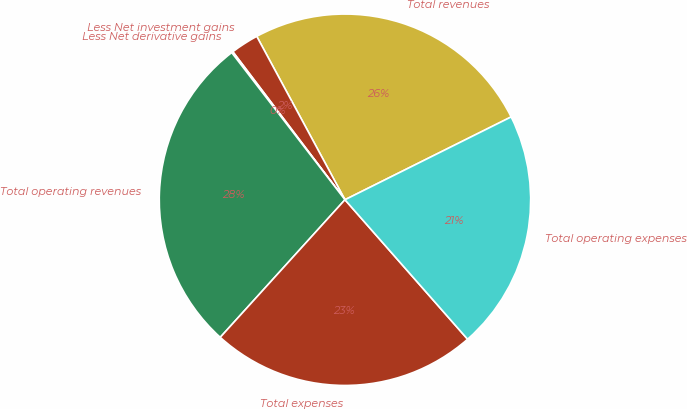Convert chart to OTSL. <chart><loc_0><loc_0><loc_500><loc_500><pie_chart><fcel>Total revenues<fcel>Less Net investment gains<fcel>Less Net derivative gains<fcel>Total operating revenues<fcel>Total expenses<fcel>Total operating expenses<nl><fcel>25.52%<fcel>2.44%<fcel>0.12%<fcel>27.84%<fcel>23.2%<fcel>20.88%<nl></chart> 